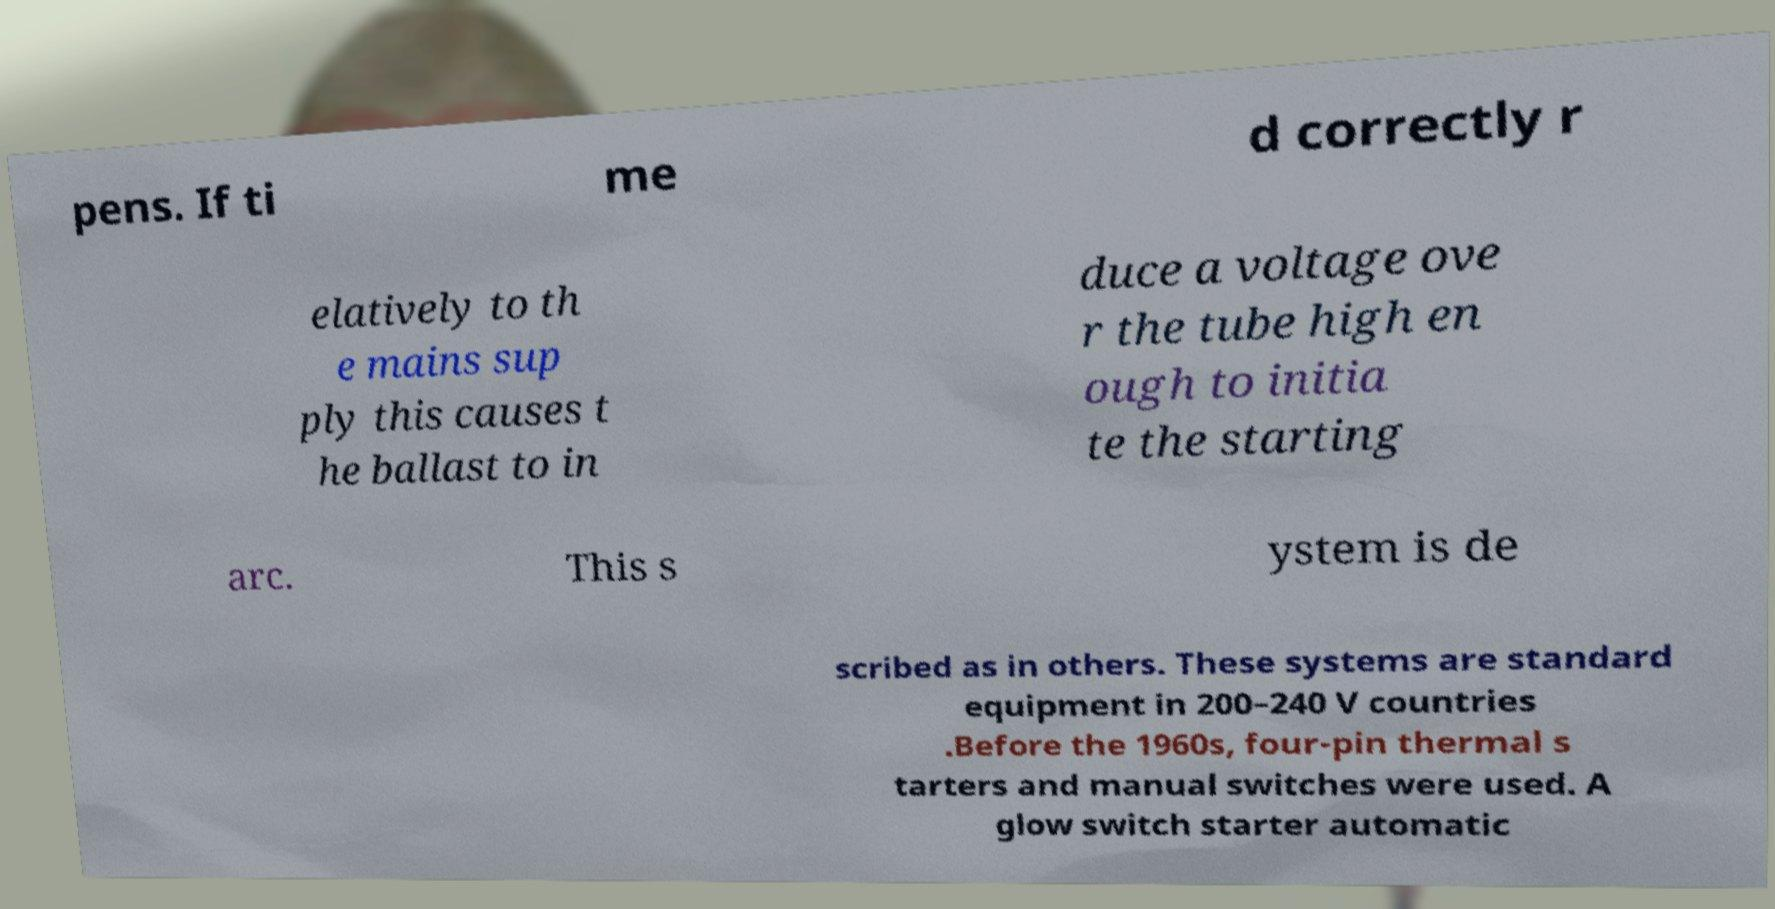I need the written content from this picture converted into text. Can you do that? pens. If ti me d correctly r elatively to th e mains sup ply this causes t he ballast to in duce a voltage ove r the tube high en ough to initia te the starting arc. This s ystem is de scribed as in others. These systems are standard equipment in 200–240 V countries .Before the 1960s, four-pin thermal s tarters and manual switches were used. A glow switch starter automatic 